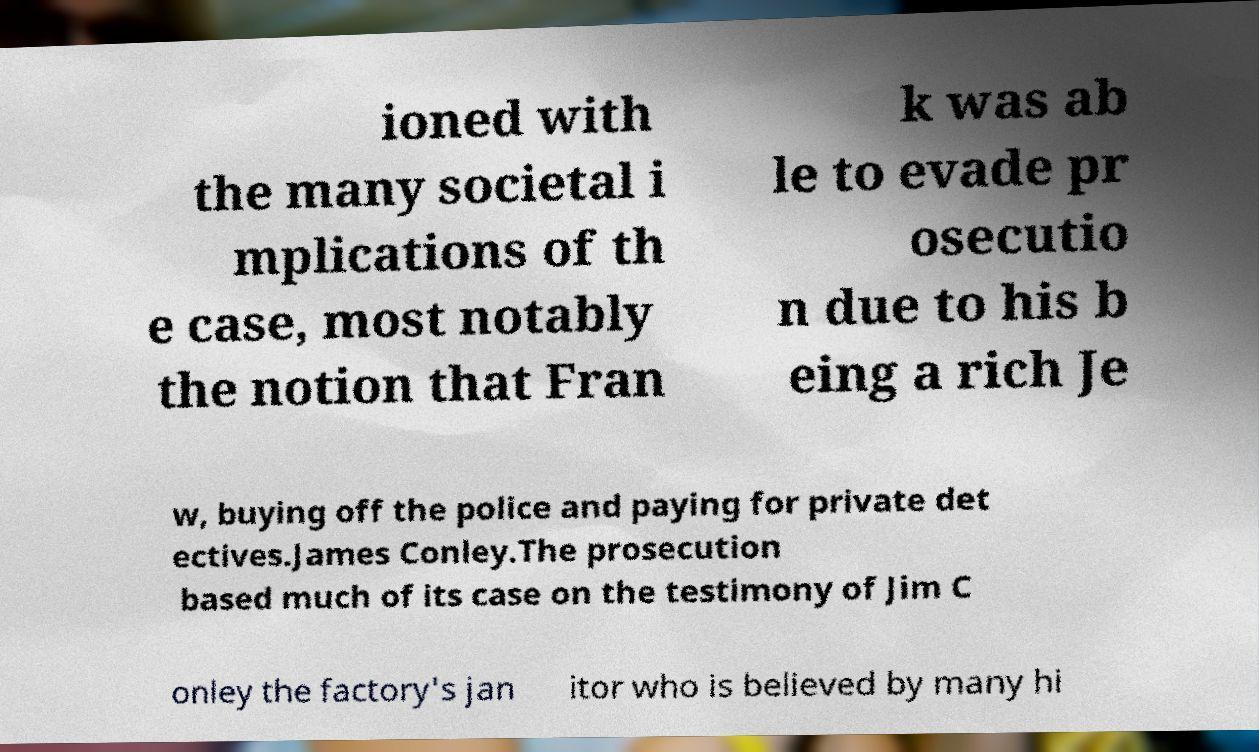Can you read and provide the text displayed in the image?This photo seems to have some interesting text. Can you extract and type it out for me? ioned with the many societal i mplications of th e case, most notably the notion that Fran k was ab le to evade pr osecutio n due to his b eing a rich Je w, buying off the police and paying for private det ectives.James Conley.The prosecution based much of its case on the testimony of Jim C onley the factory's jan itor who is believed by many hi 